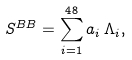<formula> <loc_0><loc_0><loc_500><loc_500>S ^ { B B } = \sum _ { i = 1 } ^ { 4 8 } a _ { i } \, \Lambda _ { i } ,</formula> 